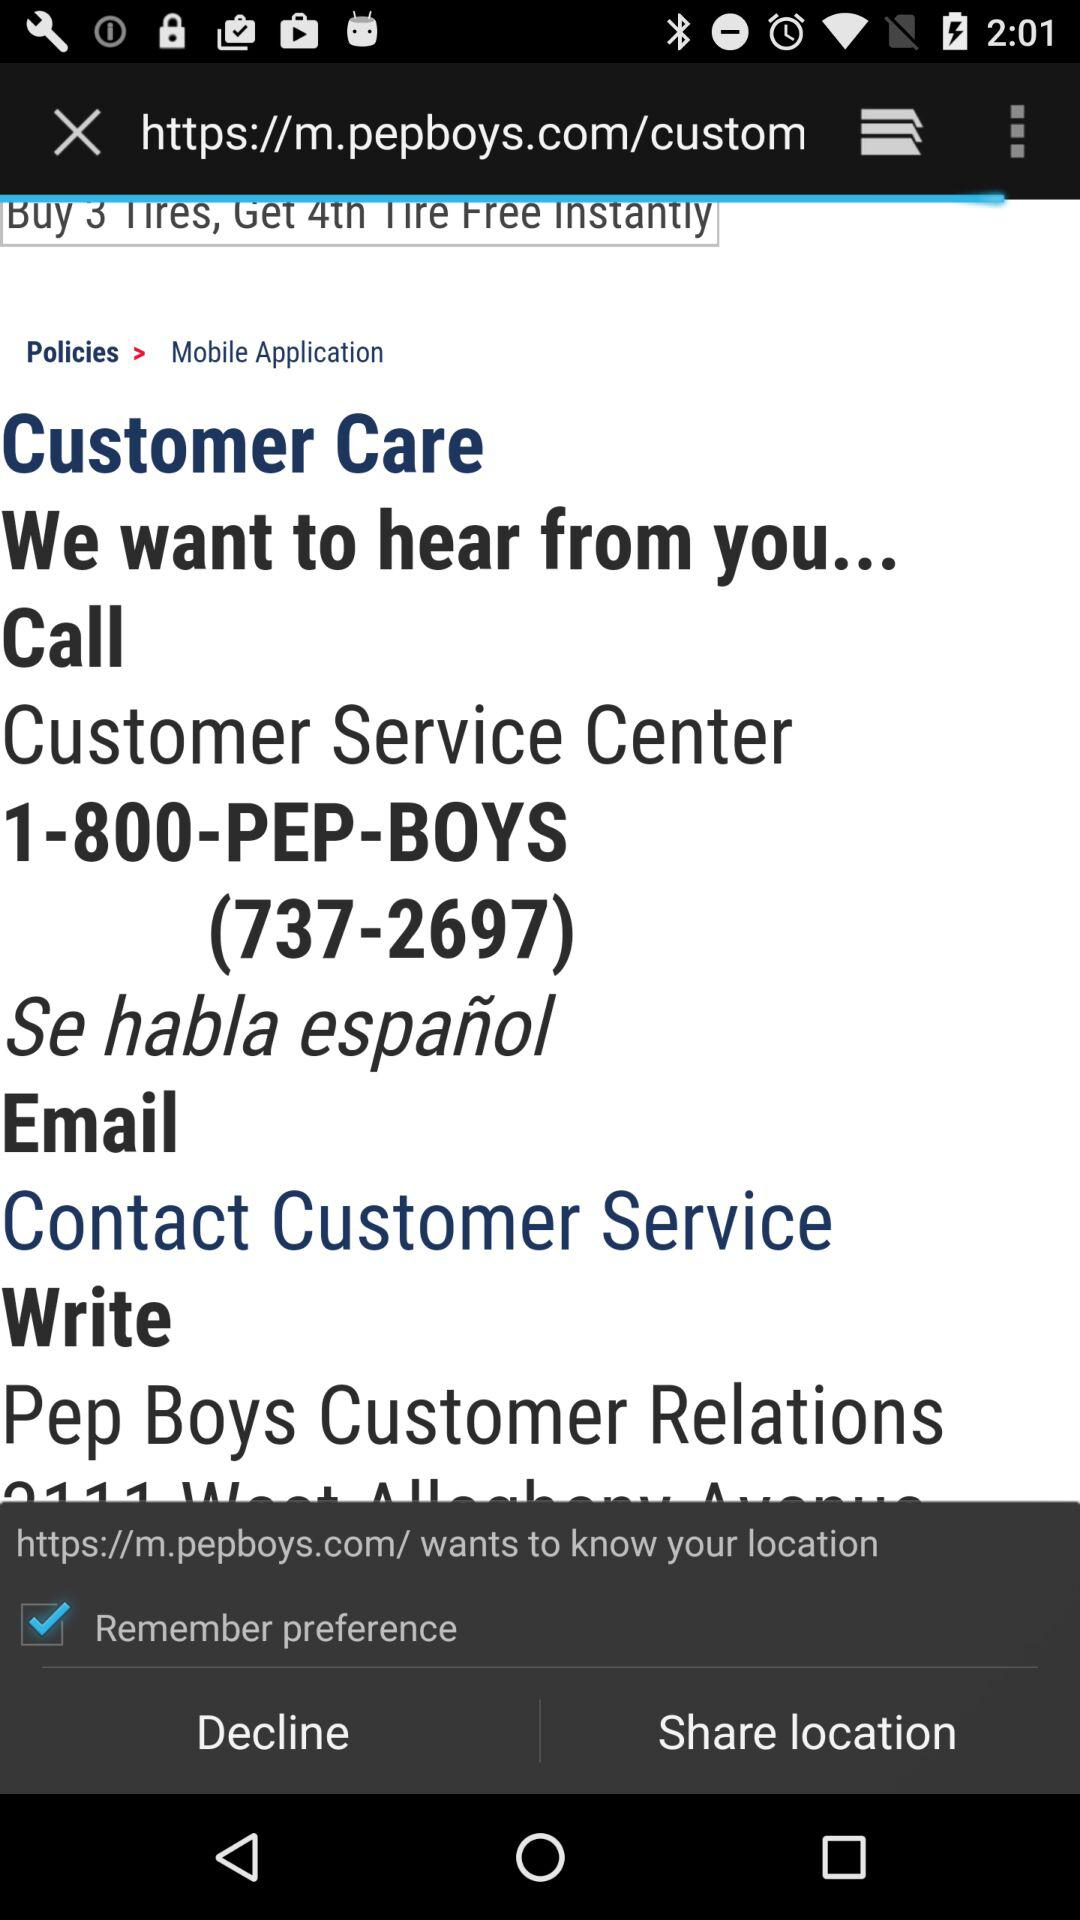What is the customer care number? The customer care number is 1-800-737-2697. 